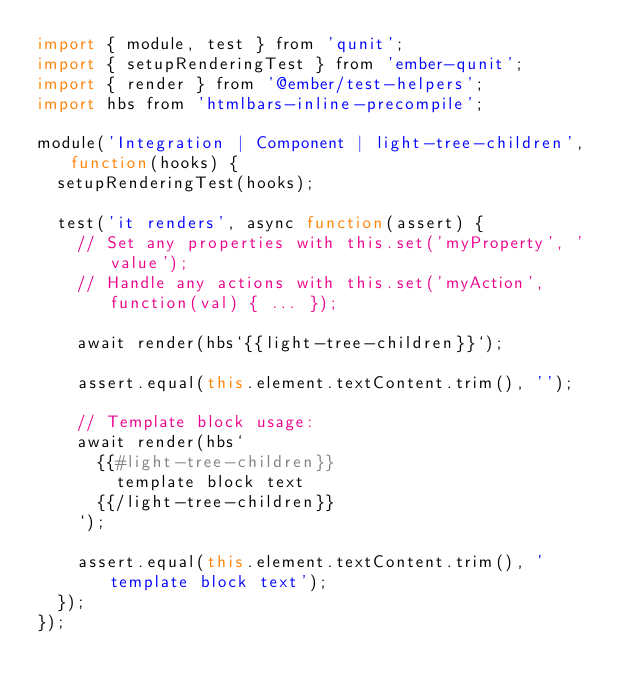Convert code to text. <code><loc_0><loc_0><loc_500><loc_500><_JavaScript_>import { module, test } from 'qunit';
import { setupRenderingTest } from 'ember-qunit';
import { render } from '@ember/test-helpers';
import hbs from 'htmlbars-inline-precompile';

module('Integration | Component | light-tree-children', function(hooks) {
  setupRenderingTest(hooks);

  test('it renders', async function(assert) {
    // Set any properties with this.set('myProperty', 'value');
    // Handle any actions with this.set('myAction', function(val) { ... });

    await render(hbs`{{light-tree-children}}`);

    assert.equal(this.element.textContent.trim(), '');

    // Template block usage:
    await render(hbs`
      {{#light-tree-children}}
        template block text
      {{/light-tree-children}}
    `);

    assert.equal(this.element.textContent.trim(), 'template block text');
  });
});
</code> 